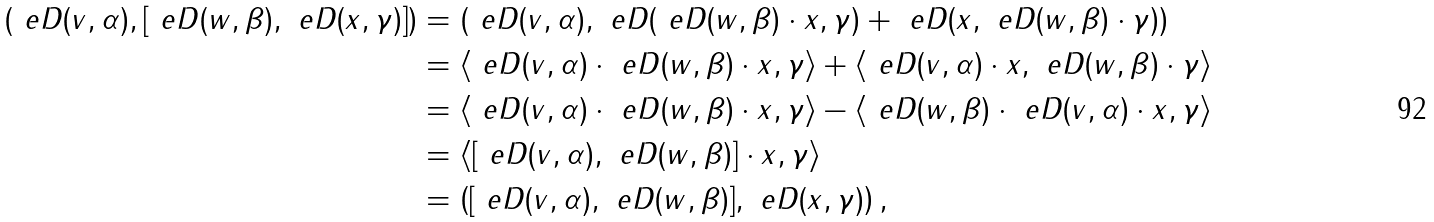<formula> <loc_0><loc_0><loc_500><loc_500>\left ( \ e D ( v , \alpha ) , [ \ e D ( w , \beta ) , \ e D ( x , \gamma ) ] \right ) & = \left ( \ e D ( v , \alpha ) , \ e D ( \ e D ( w , \beta ) \cdot x , \gamma ) + \ e D ( x , \ e D ( w , \beta ) \cdot \gamma ) \right ) \\ & = \left < \ e D ( v , \alpha ) \cdot \ e D ( w , \beta ) \cdot x , \gamma \right > + \left < \ e D ( v , \alpha ) \cdot x , \ e D ( w , \beta ) \cdot \gamma \right > \\ & = \left < \ e D ( v , \alpha ) \cdot \ e D ( w , \beta ) \cdot x , \gamma \right > - \left < \ e D ( w , \beta ) \cdot \ e D ( v , \alpha ) \cdot x , \gamma \right > \\ & = \left < [ \ e D ( v , \alpha ) , \ e D ( w , \beta ) ] \cdot x , \gamma \right > \\ & = \left ( [ \ e D ( v , \alpha ) , \ e D ( w , \beta ) ] , \ e D ( x , \gamma ) \right ) ,</formula> 